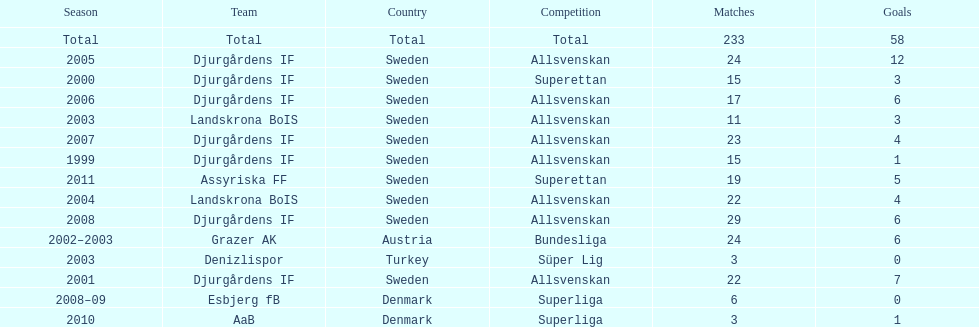What is the total number of matches? 233. 